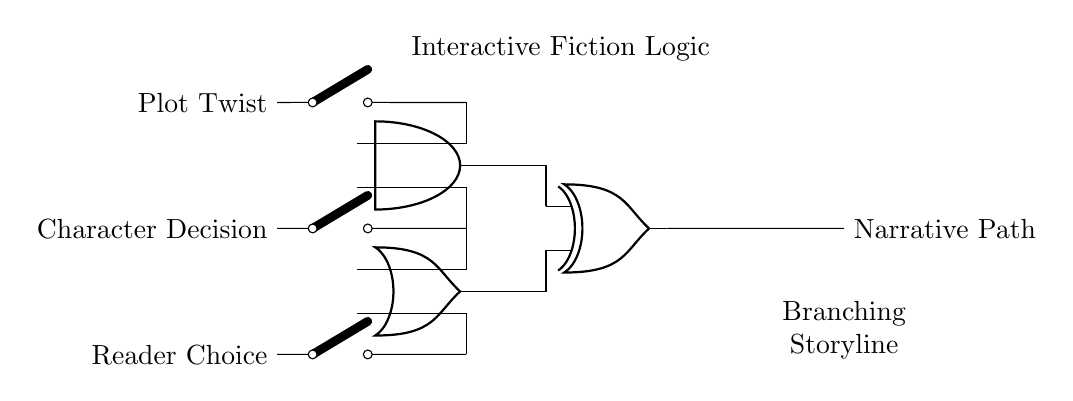What type of logic gate is at the top of the circuit? The logic gate at the top of the circuit is an AND gate. It is indicated by the shape and label in the diagram.
Answer: AND gate How many input switches are present in the circuit? The circuit diagram shows three input switches labeled as Plot Twist, Character Decision, and Reader Choice. Therefore, there are three input switches.
Answer: 3 What is the output of the last logic gate in the circuit? The last logic gate in the circuit is an XOR gate, and its output corresponds to the label "Narrative Path" which demonstrates the outcome of the logical operations performed on its inputs.
Answer: Narrative Path Which input influences the OR gate? The OR gate has two inputs that influence it: Character Decision and Reader Choice. These input paths are connected to the OR gate as shown in the diagram.
Answer: Character Decision and Reader Choice What type of logic gate combination is used before the XOR gate? The XOR gate derives its first input from an AND gate, which takes its inputs from the Plot Twist and Character Decision switches. Thus, the combination is an AND gate followed by an XOR gate.
Answer: AND and XOR What happens when all input switches are on? When all input switches (Plot Twist, Character Decision, and Reader Choice) are activated, the AND gate will output true, influencing the subsequent XOR gate. The outcome will depend on how the inputs are processed together, resulting in either a narrative path leading to a specific outcome in the story structure.
Answer: Influences narrative path 